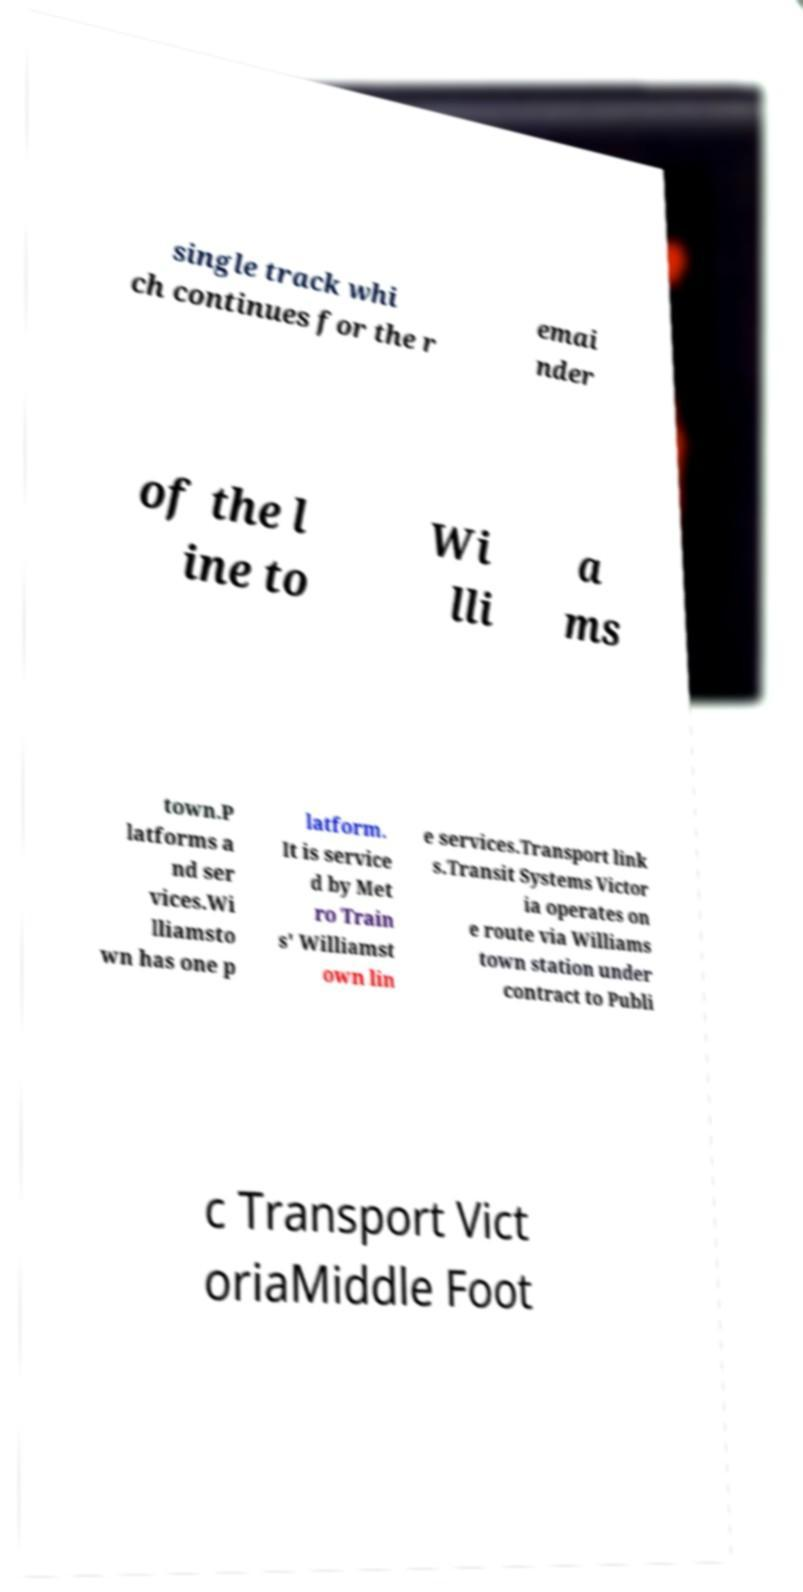What messages or text are displayed in this image? I need them in a readable, typed format. single track whi ch continues for the r emai nder of the l ine to Wi lli a ms town.P latforms a nd ser vices.Wi lliamsto wn has one p latform. It is service d by Met ro Train s' Williamst own lin e services.Transport link s.Transit Systems Victor ia operates on e route via Williams town station under contract to Publi c Transport Vict oriaMiddle Foot 